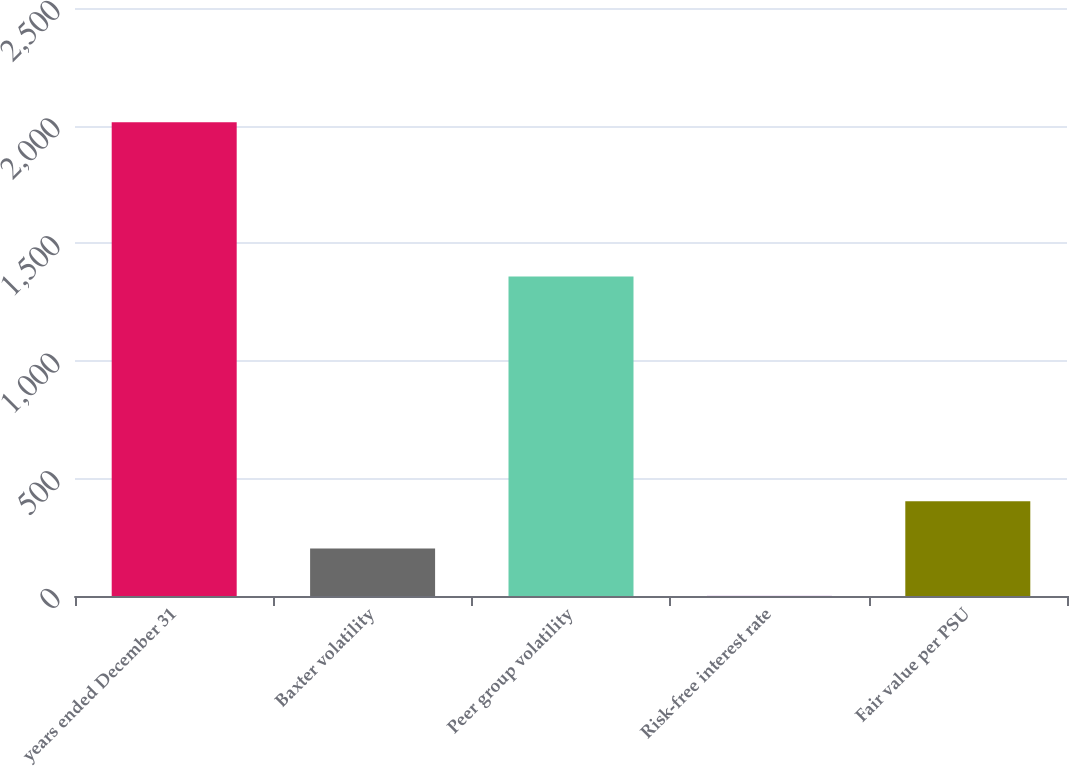<chart> <loc_0><loc_0><loc_500><loc_500><bar_chart><fcel>years ended December 31<fcel>Baxter volatility<fcel>Peer group volatility<fcel>Risk-free interest rate<fcel>Fair value per PSU<nl><fcel>2014<fcel>202.03<fcel>1358<fcel>0.7<fcel>403.36<nl></chart> 